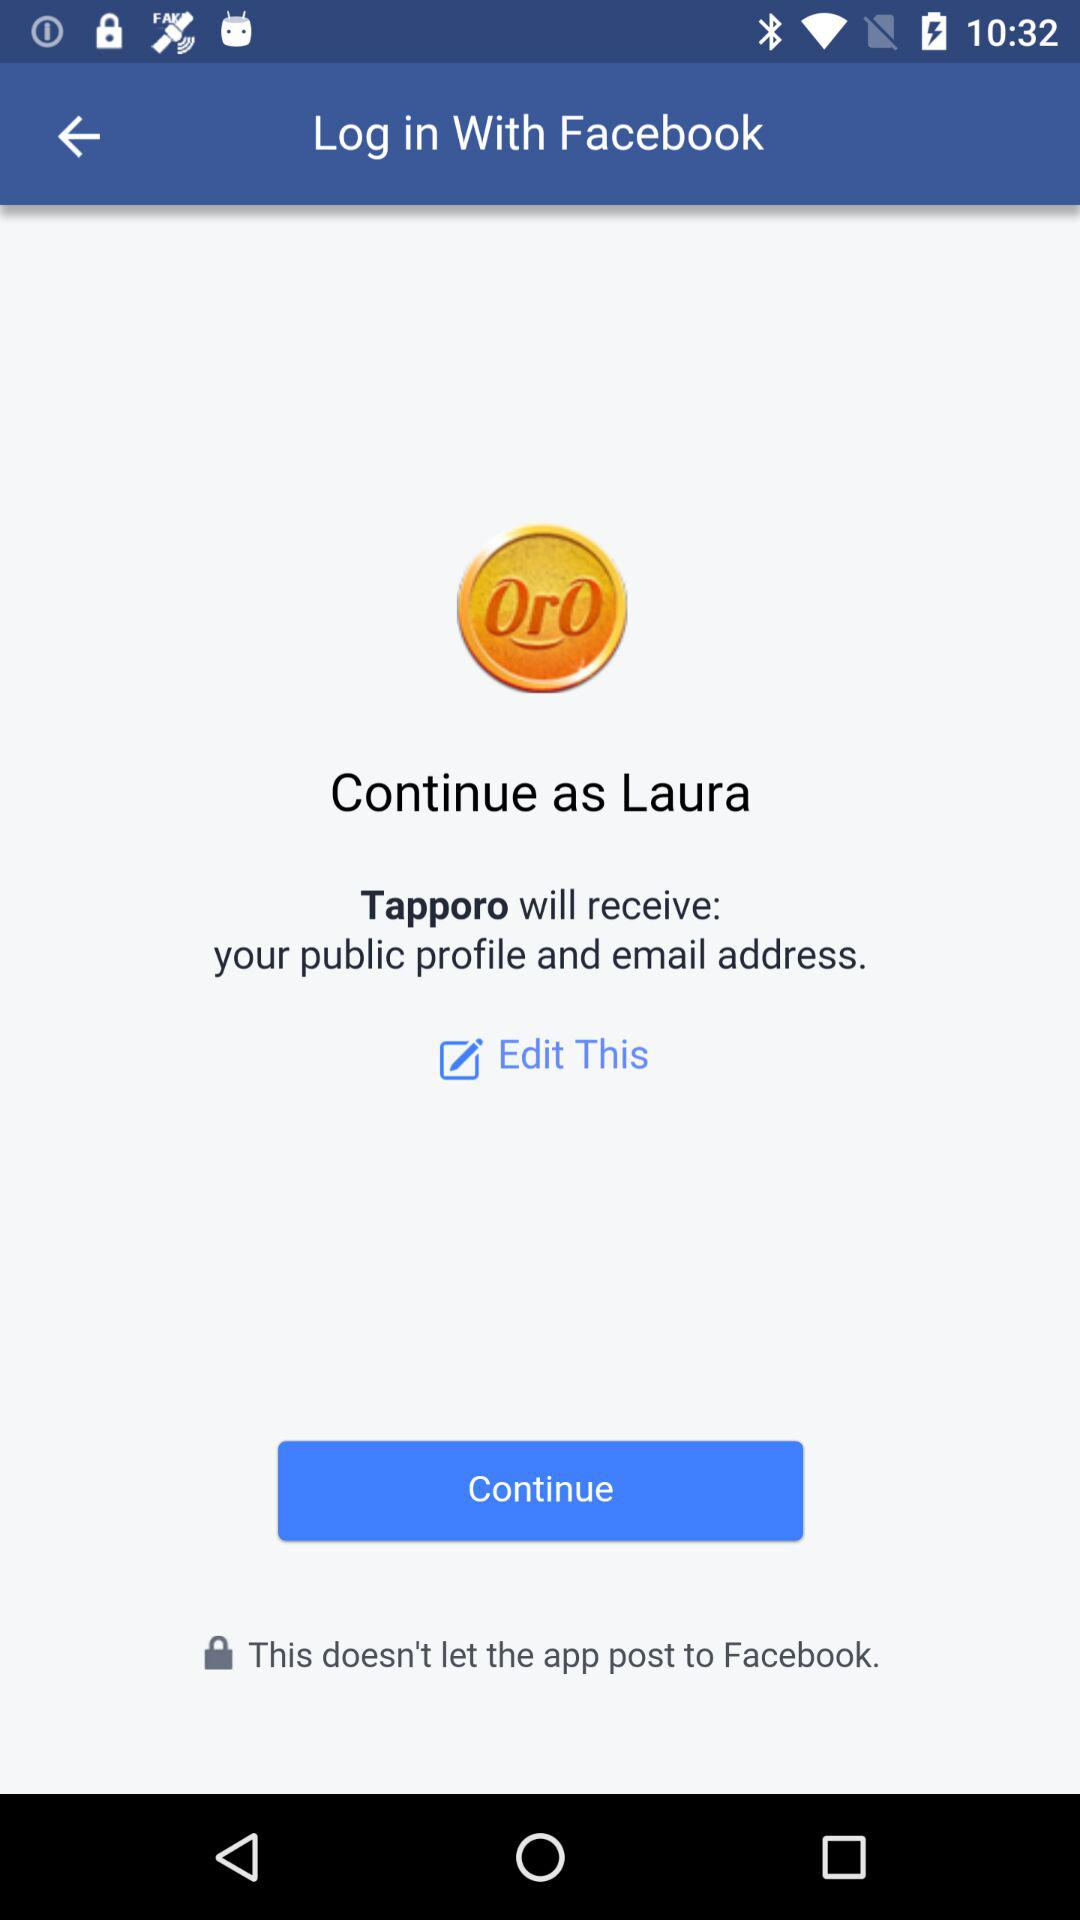What applications can be used to log in to a profile? The application is "Facebook". 